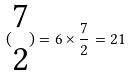<formula> <loc_0><loc_0><loc_500><loc_500>( \begin{matrix} 7 \\ 2 \end{matrix} ) = 6 \times \frac { 7 } { 2 } = 2 1</formula> 